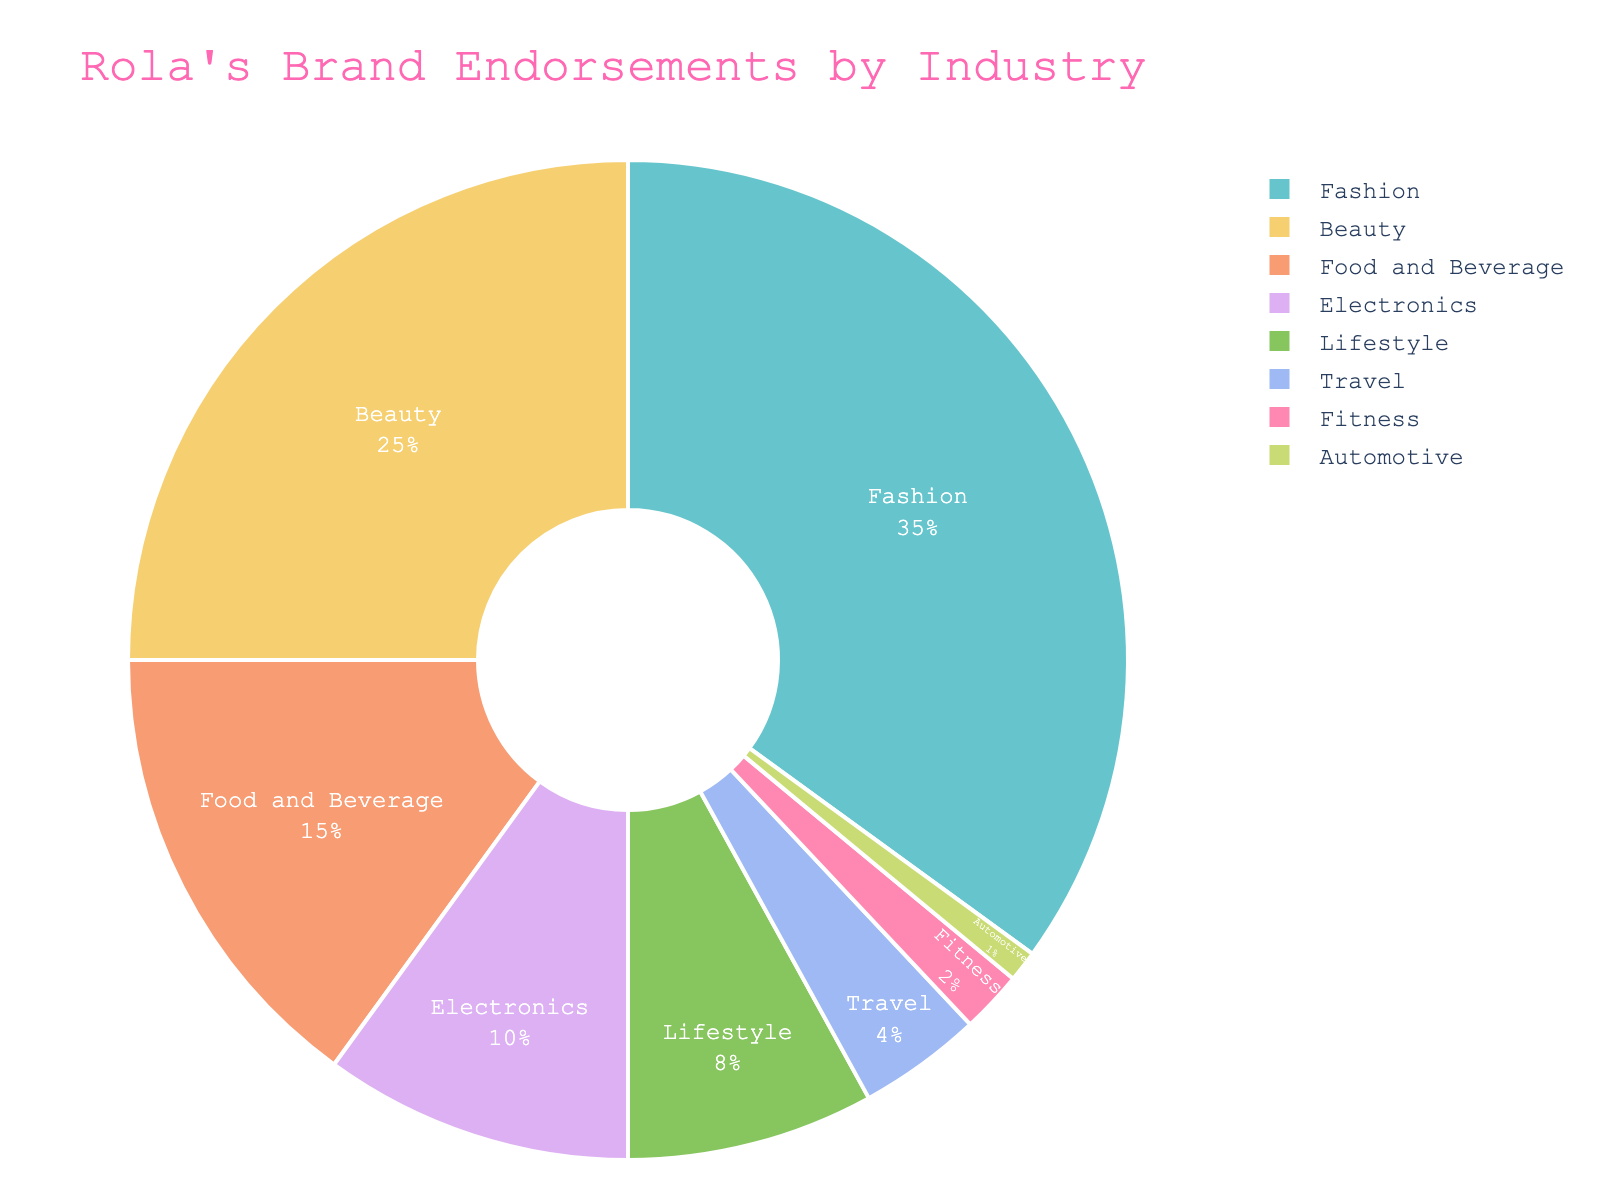What is the largest sector in Rola's brand endorsements? The largest sector can be identified by looking at the segment occupying the largest portion of the pie chart. In this case, it is the 'Fashion' segment.
Answer: Fashion Which sector has the second highest percentage of endorsements? The second largest segment after 'Fashion' is identified by the size of the slice. The 'Beauty' sector is the second largest.
Answer: Beauty What is the combined percentage of the smallest three sectors? Sum the percentages of the three smallest sectors: Fitness (2%), Automotive (1%), and Travel (4%). So, 2% + 1% + 4% = 7%.
Answer: 7% Is the percentage of endorsements in the Fashion sector greater than the combined percentage of the Food and Beverage, Electronics, and Lifestyle sectors? The percentage for Fashion is 35%. The combined percentage for Food and Beverage (15%), Electronics (10%), and Lifestyle (8%) is 15% + 10% + 8% = 33%, which is less than 35%.
Answer: Yes Which color represents the Electronics sector, and how much percentage does it occupy? Identify the color in the pie chart legend that matches the 'Electronics' label and the associated percentage value in the figure. The segment labeled 'Electronics' occupies 10%.
Answer: It occupies 10% What is the difference in percentage between the Beauty and Lifestyle sectors? Subtract the percentage of the Lifestyle sector from the Beauty sector: Beauty (25%) - Lifestyle (8%) = 17%.
Answer: 17% Rank the sectors by their percentage of endorsements from highest to lowest. Order the sectors based on their percentage values: Fashion (35%), Beauty (25%), Food and Beverage (15%), Electronics (10%), Lifestyle (8%), Travel (4%), Fitness (2%), Automotive (1%).
Answer: Fashion > Beauty > Food and Beverage > Electronics > Lifestyle > Travel > Fitness > Automotive Is the percentage of endorsements in the Beauty sector greater than the Travel, Fitness, and Automotive sectors combined? The percentage for Beauty is 25%. The combined percentage for Travel (4%), Fitness (2%), and Automotive (1%) is 4% + 2% + 1% = 7%, which is less than 25%.
Answer: Yes What is the combined percentage of the top two sectors? Sum the percentages of Fashion and Beauty sectors: 35% + 25% = 60%.
Answer: 60% If endorsements for Electronic and Lifestyle sectors were to be doubled, what would their combined new percentage be? Calculate the new percentage for Electronics as 10% * 2 = 20% and for Lifestyle as 8% * 2 = 16%. Their combined new percentage is 20% + 16% = 36%.
Answer: 36% 